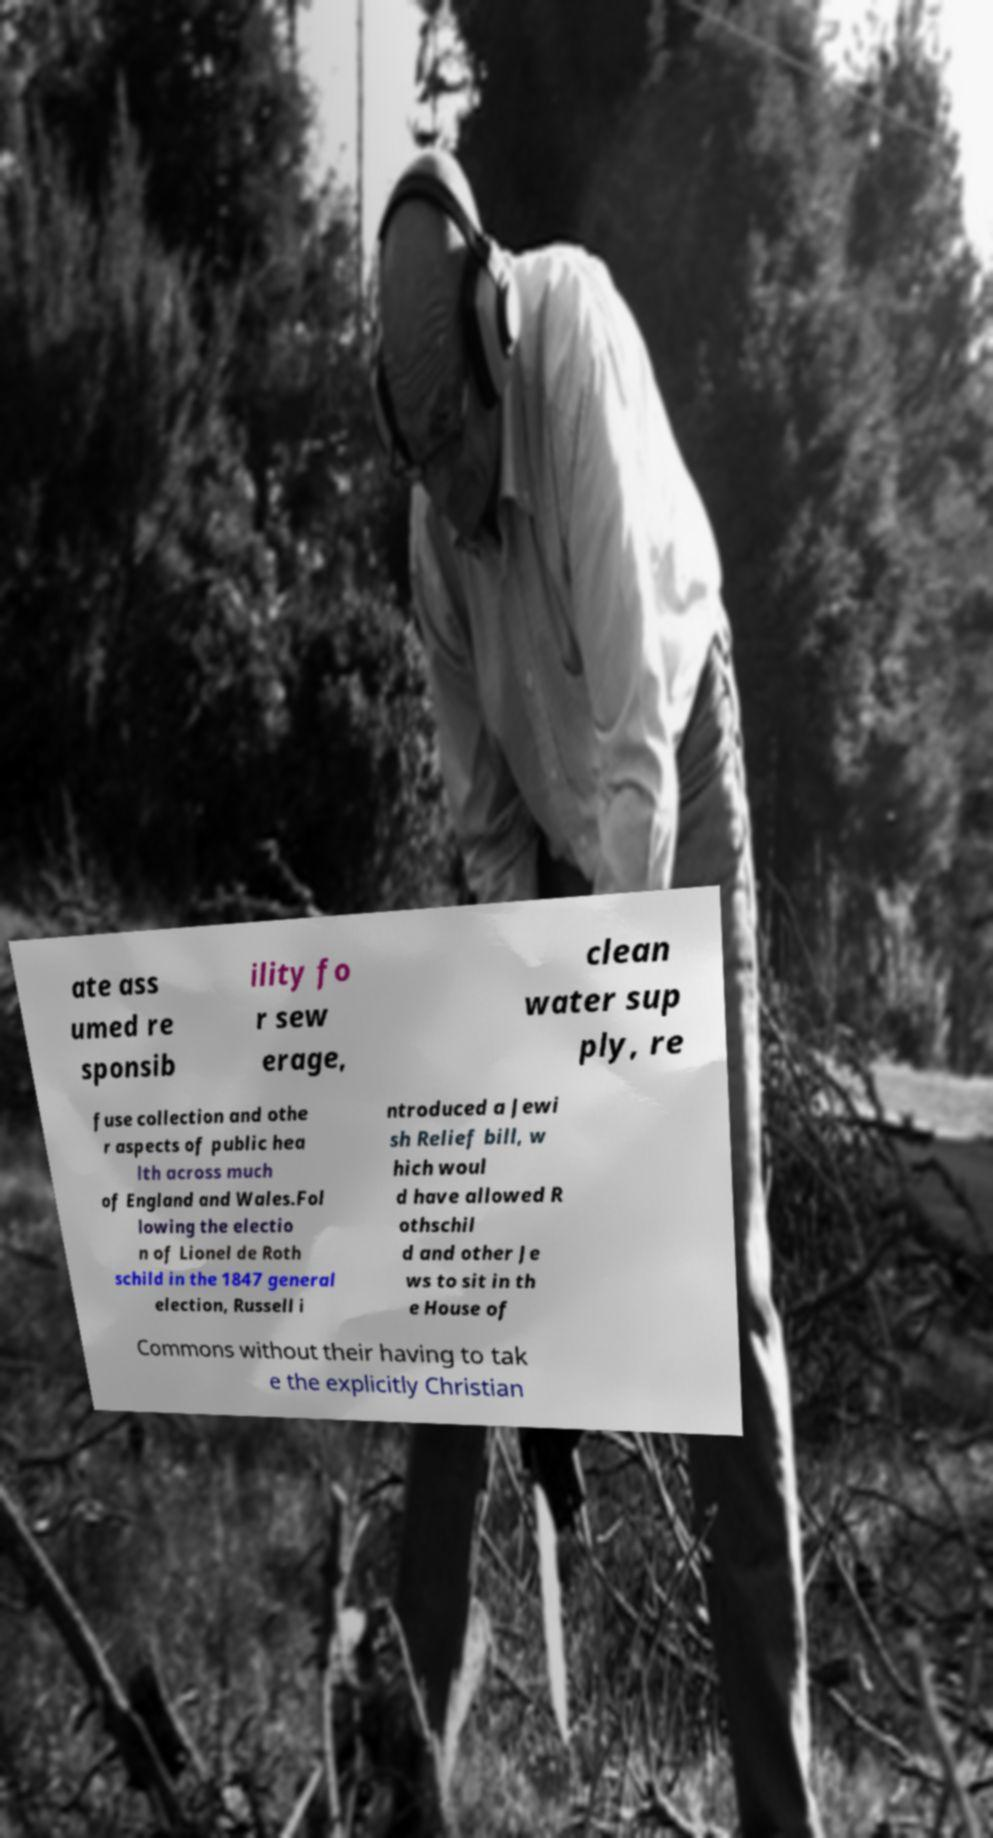What messages or text are displayed in this image? I need them in a readable, typed format. ate ass umed re sponsib ility fo r sew erage, clean water sup ply, re fuse collection and othe r aspects of public hea lth across much of England and Wales.Fol lowing the electio n of Lionel de Roth schild in the 1847 general election, Russell i ntroduced a Jewi sh Relief bill, w hich woul d have allowed R othschil d and other Je ws to sit in th e House of Commons without their having to tak e the explicitly Christian 